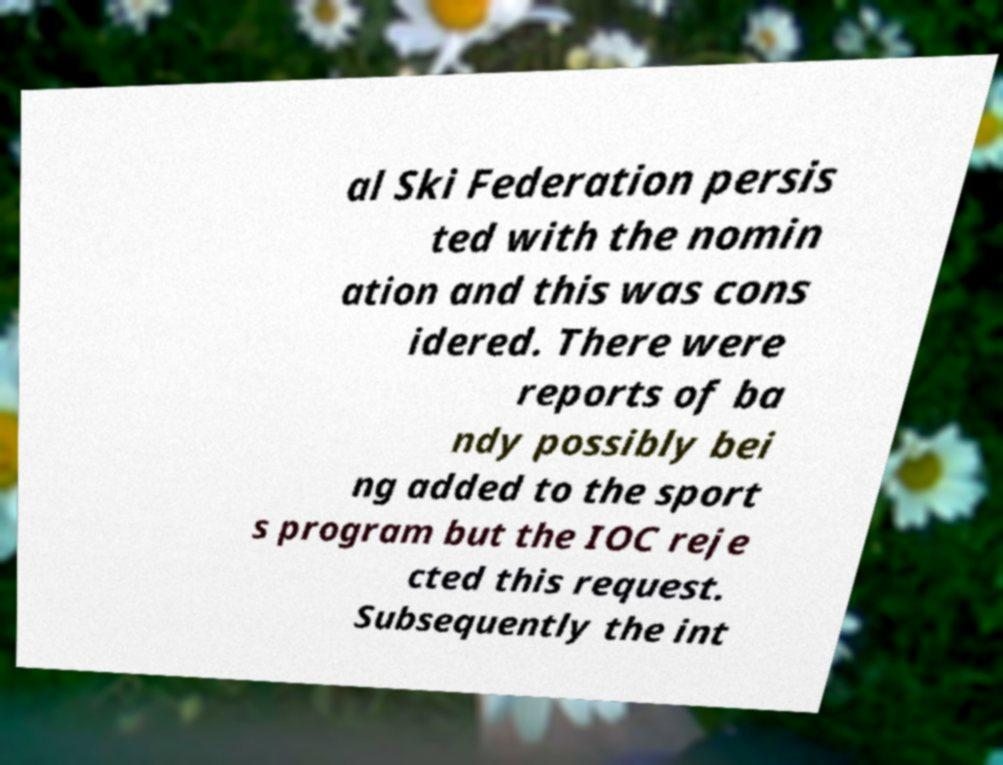Please read and relay the text visible in this image. What does it say? al Ski Federation persis ted with the nomin ation and this was cons idered. There were reports of ba ndy possibly bei ng added to the sport s program but the IOC reje cted this request. Subsequently the int 